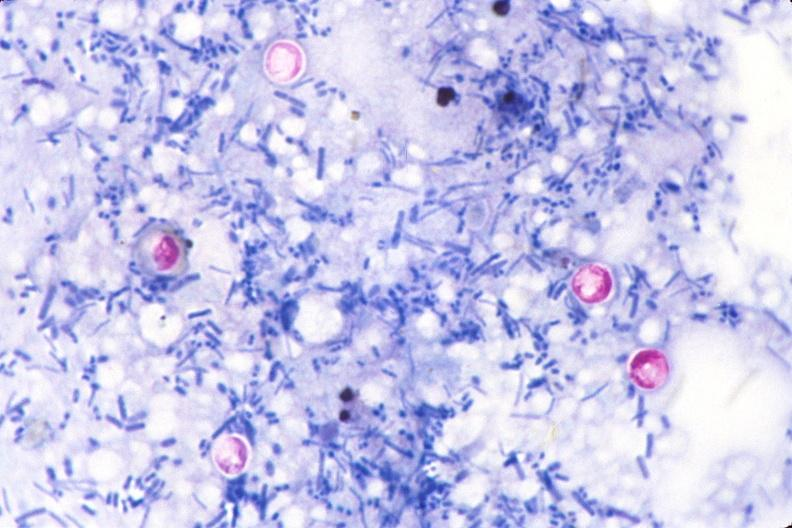where is this from?
Answer the question using a single word or phrase. Gastrointestinal system 